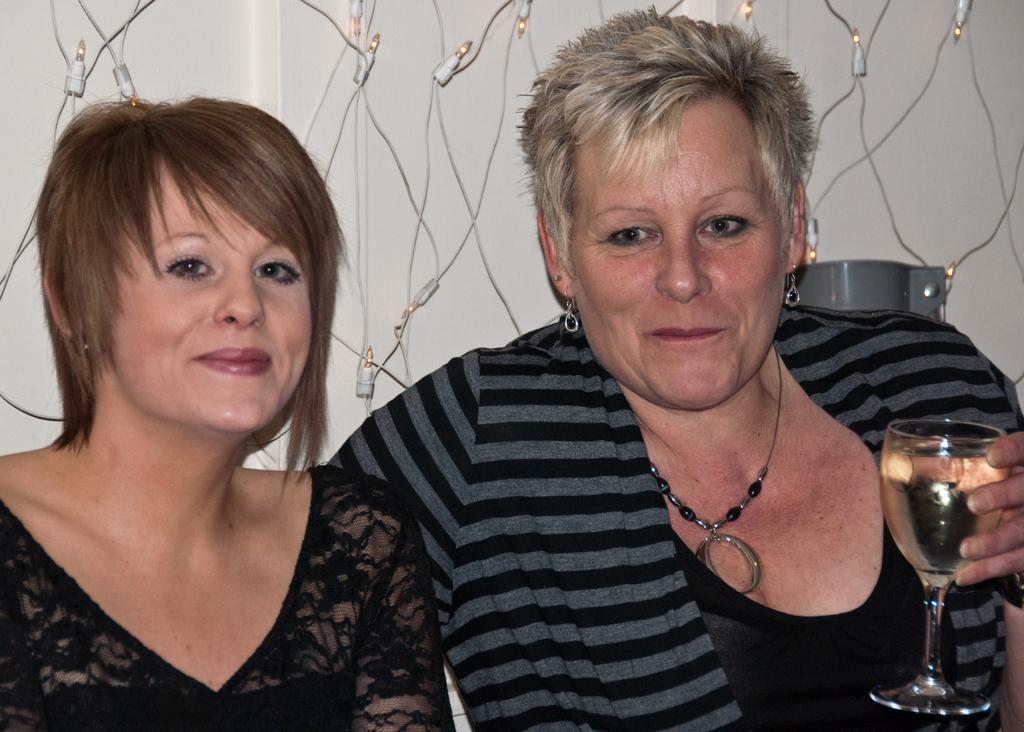How many women are in the image? There are two women in the image. What is the woman on the right side holding? The woman on the right side is holding a glass. What is in the glass? The glass contains a drink. What can be seen in the background of the image? There is a wall in the background of the image. What is attached to the wall? The wall has small lights and wires hanging on it. What type of yoke is visible in the image? There is no yoke present in the image. How many toes can be seen on the women's feet in the image? The image does not show the women's feet, so the number of toes cannot be determined. 